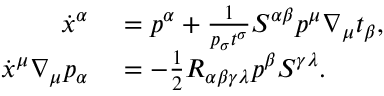<formula> <loc_0><loc_0><loc_500><loc_500>\begin{array} { r l } { \dot { x } ^ { \alpha } } & = p ^ { \alpha } + \frac { 1 } { p _ { \sigma } t ^ { \sigma } } S ^ { \alpha \beta } p ^ { \mu } \nabla _ { \mu } t _ { \beta } , } \\ { \dot { x } ^ { \mu } \nabla _ { \mu } p _ { \alpha } } & = - \frac { 1 } { 2 } R _ { \alpha \beta \gamma \lambda } p ^ { \beta } S ^ { \gamma \lambda } . } \end{array}</formula> 